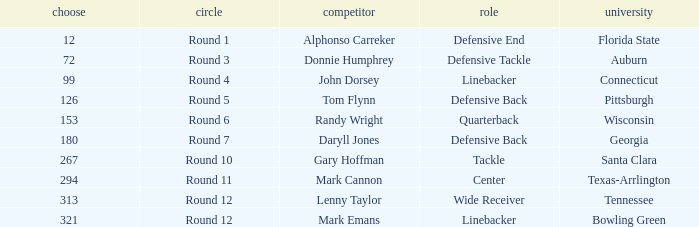What Player is a Wide Receiver? Lenny Taylor. 